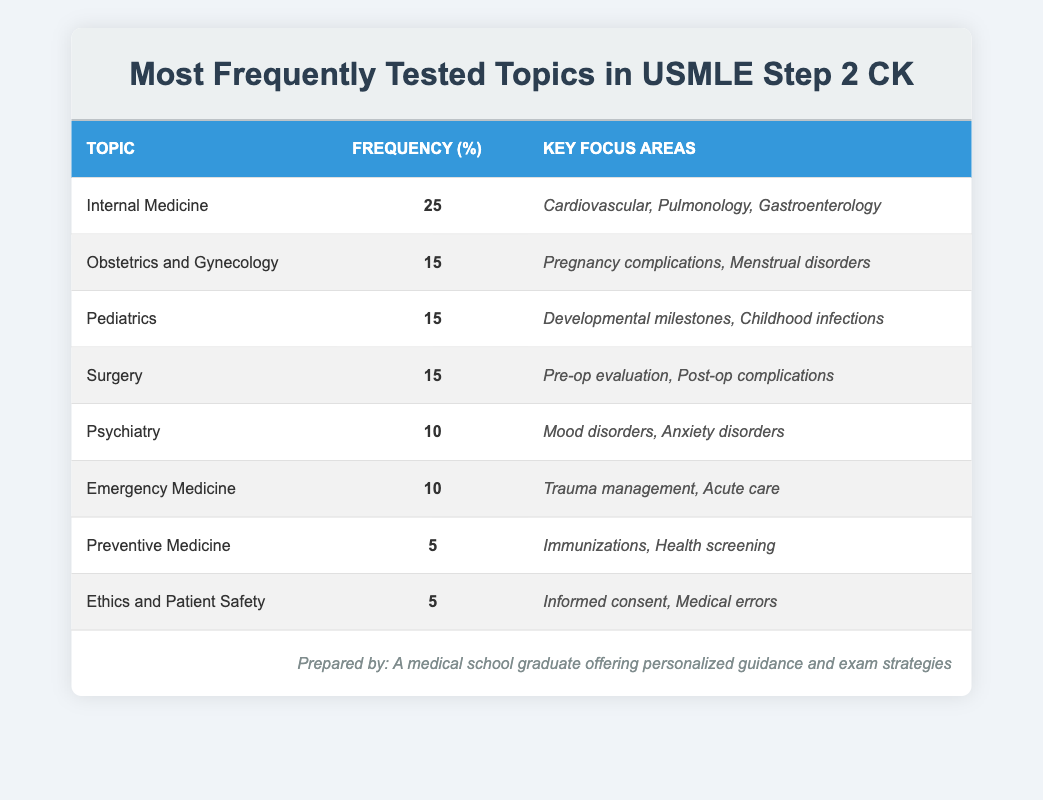What is the most frequently tested topic in the USMLE Step 2 CK exam? The table shows that Internal Medicine has the highest frequency percentage at 25%.
Answer: Internal Medicine How many topics have a frequency of 15%? The table lists three topics with a frequency of 15%: Obstetrics and Gynecology, Pediatrics, and Surgery.
Answer: 3 What is the total frequency percentage for Internal Medicine, Pediatrics, and Psychiatry combined? We add the frequency percentages: 25% (Internal Medicine) + 15% (Pediatrics) + 10% (Psychiatry) = 50%.
Answer: 50% Is Trauma Management a focus area in Emergency Medicine as per the table? Yes, the table specifically lists Trauma Management under the Key Focus Areas for Emergency Medicine.
Answer: Yes Which topics have a frequency of 5% and what are their key focus areas? The table includes Preventive Medicine and Ethics and Patient Safety with 5% frequency. Their focus areas are Immunizations and Health Screening, and Informed Consent and Medical Errors, respectively.
Answer: Preventive Medicine (Immunizations, Health Screening), Ethics and Patient Safety (Informed Consent, Medical Errors) What is the average frequency of the topics listed in the table? There are eight topics. Summing their frequencies gives 25 + 15 + 15 + 15 + 10 + 10 + 5 + 5 = 90. Then, divide by 8 (the number of topics): 90 / 8 = 11.25%.
Answer: 11.25% Which has a lower frequency: Psychiatry or Preventive Medicine? The table shows Psychiatry at 10% and Preventive Medicine at 5%. Since 5% is less than 10%, Preventive Medicine has a lower frequency.
Answer: Preventive Medicine If you combine the frequencies of Obstetrics and Gynecology and Surgery, what value do you get? Adding the two frequencies together gives 15% (Obstetrics and Gynecology) + 15% (Surgery) = 30%.
Answer: 30% 